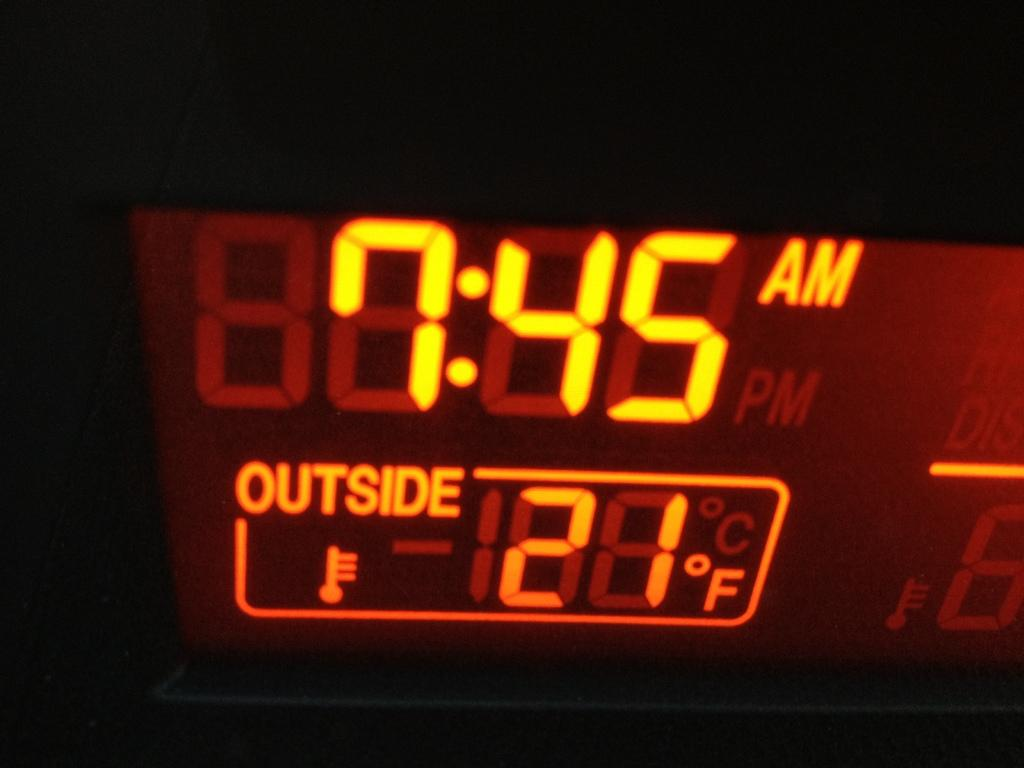<image>
Create a compact narrative representing the image presented. A digital clock displays the time of 7:45 AM and outside temperature of 21 degrees in yellow letters. 